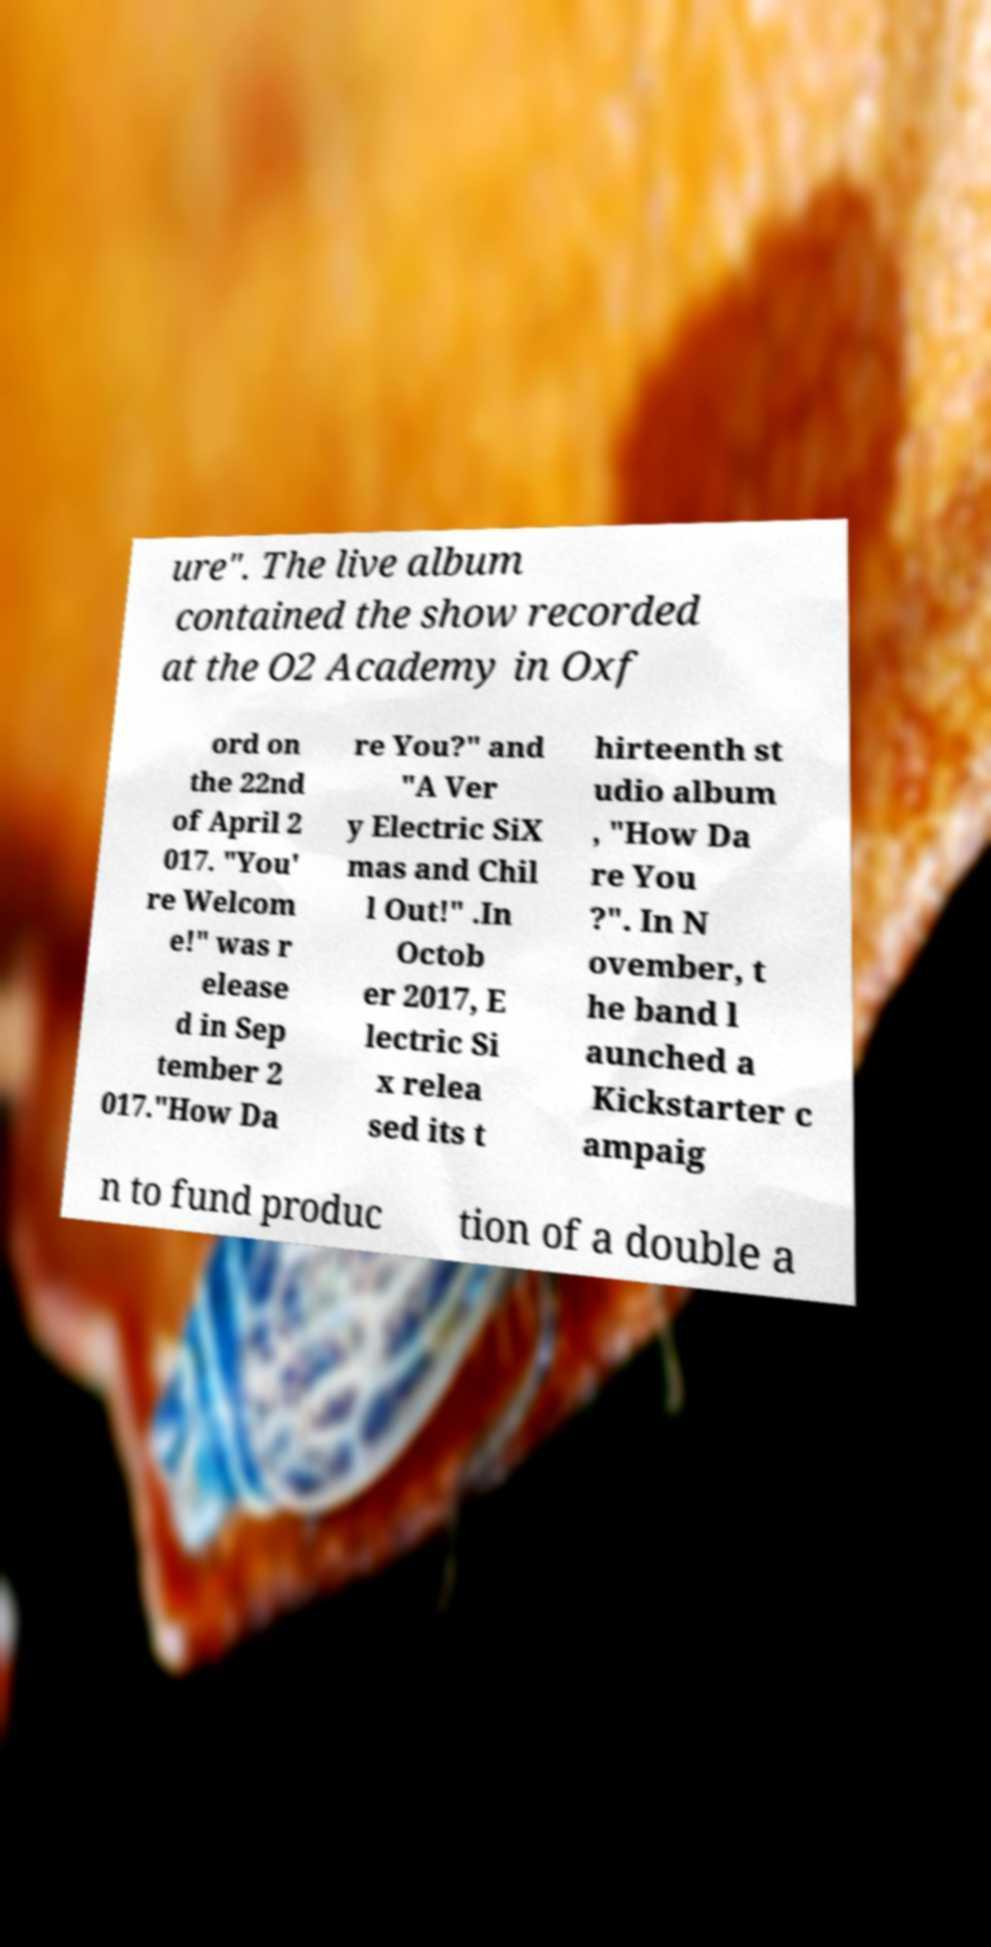Could you extract and type out the text from this image? ure". The live album contained the show recorded at the O2 Academy in Oxf ord on the 22nd of April 2 017. "You' re Welcom e!" was r elease d in Sep tember 2 017."How Da re You?" and "A Ver y Electric SiX mas and Chil l Out!" .In Octob er 2017, E lectric Si x relea sed its t hirteenth st udio album , "How Da re You ?". In N ovember, t he band l aunched a Kickstarter c ampaig n to fund produc tion of a double a 